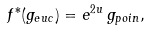<formula> <loc_0><loc_0><loc_500><loc_500>f ^ { * } ( g _ { e u c } ) = e ^ { 2 u } \, g _ { p o i n } ,</formula> 